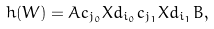Convert formula to latex. <formula><loc_0><loc_0><loc_500><loc_500>h ( W ) = A c _ { j _ { 0 } } X d _ { i _ { 0 } } c _ { j _ { 1 } } X d _ { i _ { 1 } } B ,</formula> 